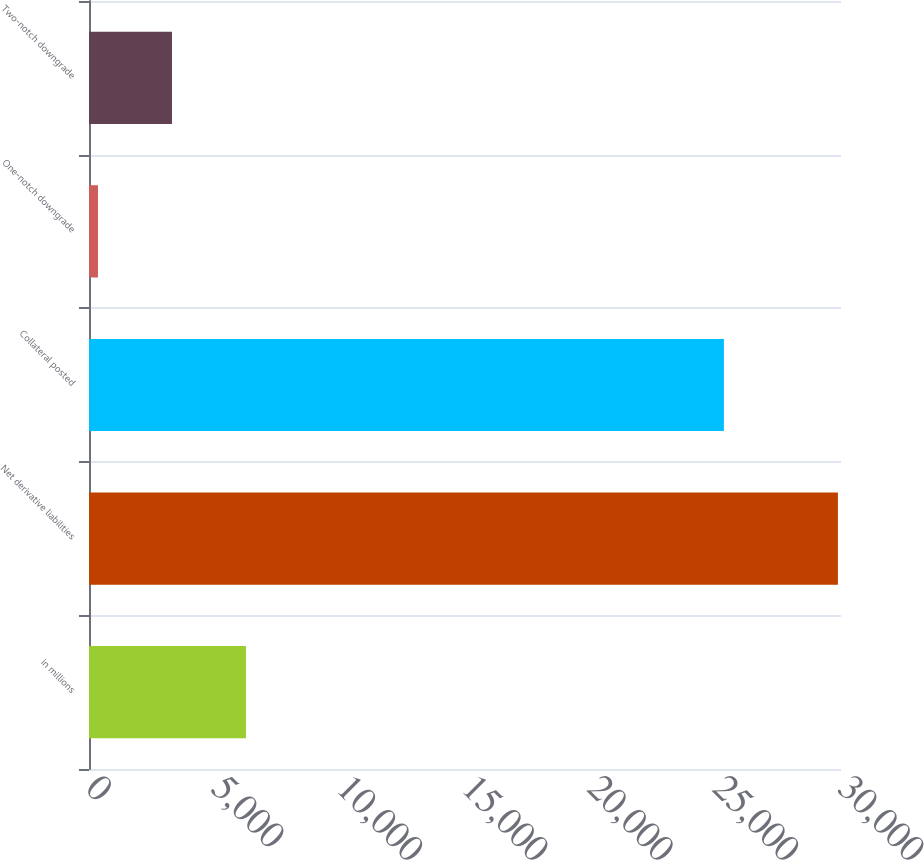<chart> <loc_0><loc_0><loc_500><loc_500><bar_chart><fcel>in millions<fcel>Net derivative liabilities<fcel>Collateral posted<fcel>One-notch downgrade<fcel>Two-notch downgrade<nl><fcel>6261.8<fcel>29877<fcel>25329<fcel>358<fcel>3309.9<nl></chart> 